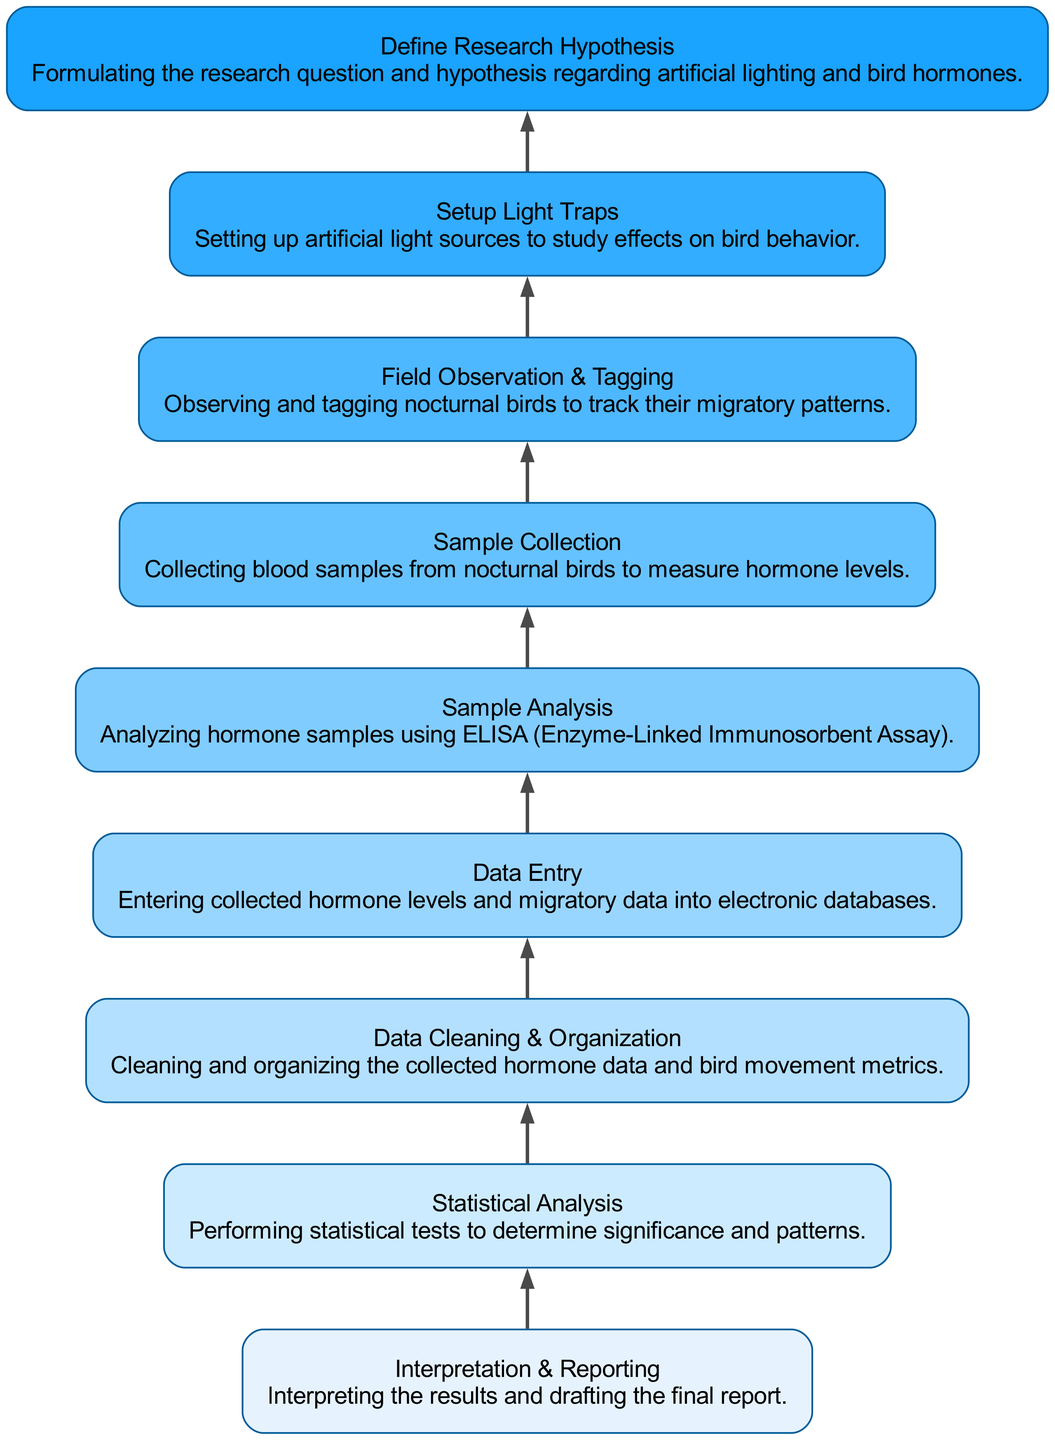What is the starting point of the evaluation process? The starting point of the flowchart is "Define Research Hypothesis", which is the first step listed at the bottom of the diagram.
Answer: Define Research Hypothesis How many total nodes are there in the diagram? By counting all the distinct steps in the flowchart, there are eight nodes represented by the actions or processes mentioned.
Answer: Eight What is the last step in the evaluation process? The last step as we move upward through the flowchart is "Interpretation & Reporting", which is the final activity conducted after statistical analysis.
Answer: Interpretation & Reporting Which step directly follows "Sample Analysis"? According to the flow of the diagram, "Data Entry" directly follows "Sample Analysis". This means that after analyzing the samples, the data must be entered into a database.
Answer: Data Entry What process comes before "Statistical Analysis"? "Data Cleaning & Organization" occurs just before "Statistical Analysis", indicating that the data must be cleaned and organized before any statistical tests can be performed.
Answer: Data Cleaning & Organization How does "Setup Light Traps" connect to "Field Observation & Tagging"? "Setup Light Traps" is handled before "Field Observation & Tagging", showing a direct relationship where light traps are set up to study behavioral responses during the tagging of birds for observing migratory patterns.
Answer: Directly precedes What does "Sample Collection" feed into? "Sample Collection" directly feeds into "Sample Analysis", as the collected samples are analyzed next in the process flow indicated in the diagram.
Answer: Sample Analysis Which node immediately follows "Define Research Hypothesis"? "Setup Light Traps" immediately follows "Define Research Hypothesis", showcasing that after defining the hypothesis, the setup of light traps is the next logical step.
Answer: Setup Light Traps What is the purpose of "Statistical Analysis" in the evaluation process? The purpose of "Statistical Analysis" is to perform statistical tests to determine significance and identify patterns within the data collected throughout the study.
Answer: Determine significance and patterns 